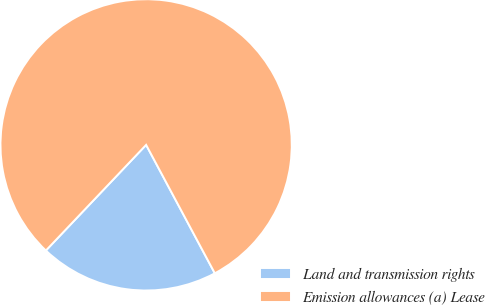Convert chart. <chart><loc_0><loc_0><loc_500><loc_500><pie_chart><fcel>Land and transmission rights<fcel>Emission allowances (a) Lease<nl><fcel>19.9%<fcel>80.1%<nl></chart> 